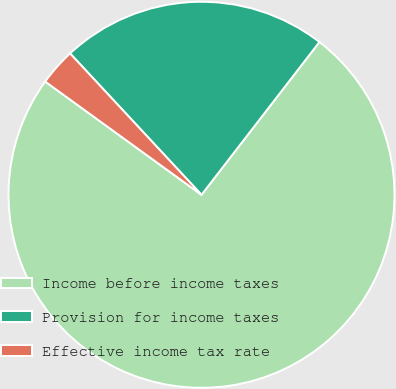<chart> <loc_0><loc_0><loc_500><loc_500><pie_chart><fcel>Income before income taxes<fcel>Provision for income taxes<fcel>Effective income tax rate<nl><fcel>74.51%<fcel>22.38%<fcel>3.1%<nl></chart> 